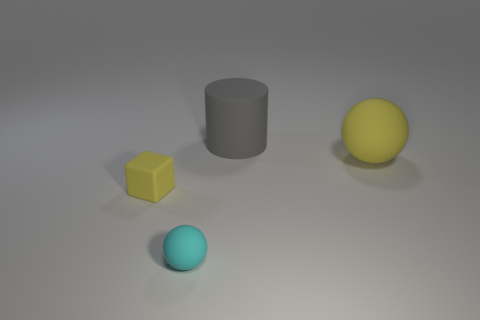Add 3 big yellow rubber balls. How many objects exist? 7 Subtract all cylinders. How many objects are left? 3 Subtract all gray cylinders. How many brown blocks are left? 0 Subtract 1 gray cylinders. How many objects are left? 3 Subtract all purple cylinders. Subtract all yellow cubes. How many cylinders are left? 1 Subtract all large yellow rubber balls. Subtract all large matte cylinders. How many objects are left? 2 Add 4 cyan matte spheres. How many cyan matte spheres are left? 5 Add 1 tiny cyan metal things. How many tiny cyan metal things exist? 1 